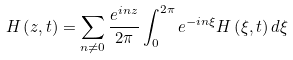Convert formula to latex. <formula><loc_0><loc_0><loc_500><loc_500>H \left ( z , t \right ) = \sum _ { n \neq 0 } \frac { e ^ { i n z } } { 2 \pi } \int _ { 0 } ^ { 2 \pi } e ^ { - i n \xi } H \left ( \xi , t \right ) d \xi</formula> 